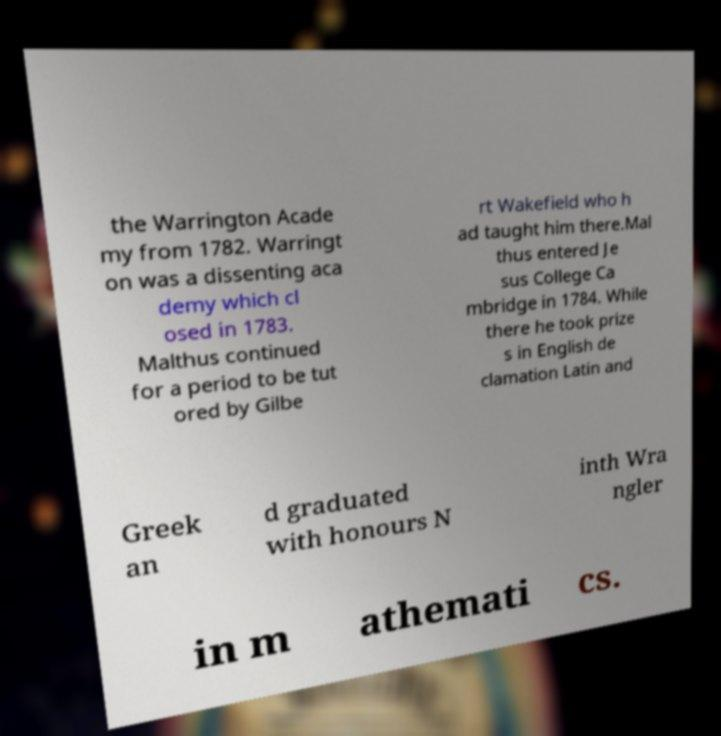Could you assist in decoding the text presented in this image and type it out clearly? the Warrington Acade my from 1782. Warringt on was a dissenting aca demy which cl osed in 1783. Malthus continued for a period to be tut ored by Gilbe rt Wakefield who h ad taught him there.Mal thus entered Je sus College Ca mbridge in 1784. While there he took prize s in English de clamation Latin and Greek an d graduated with honours N inth Wra ngler in m athemati cs. 